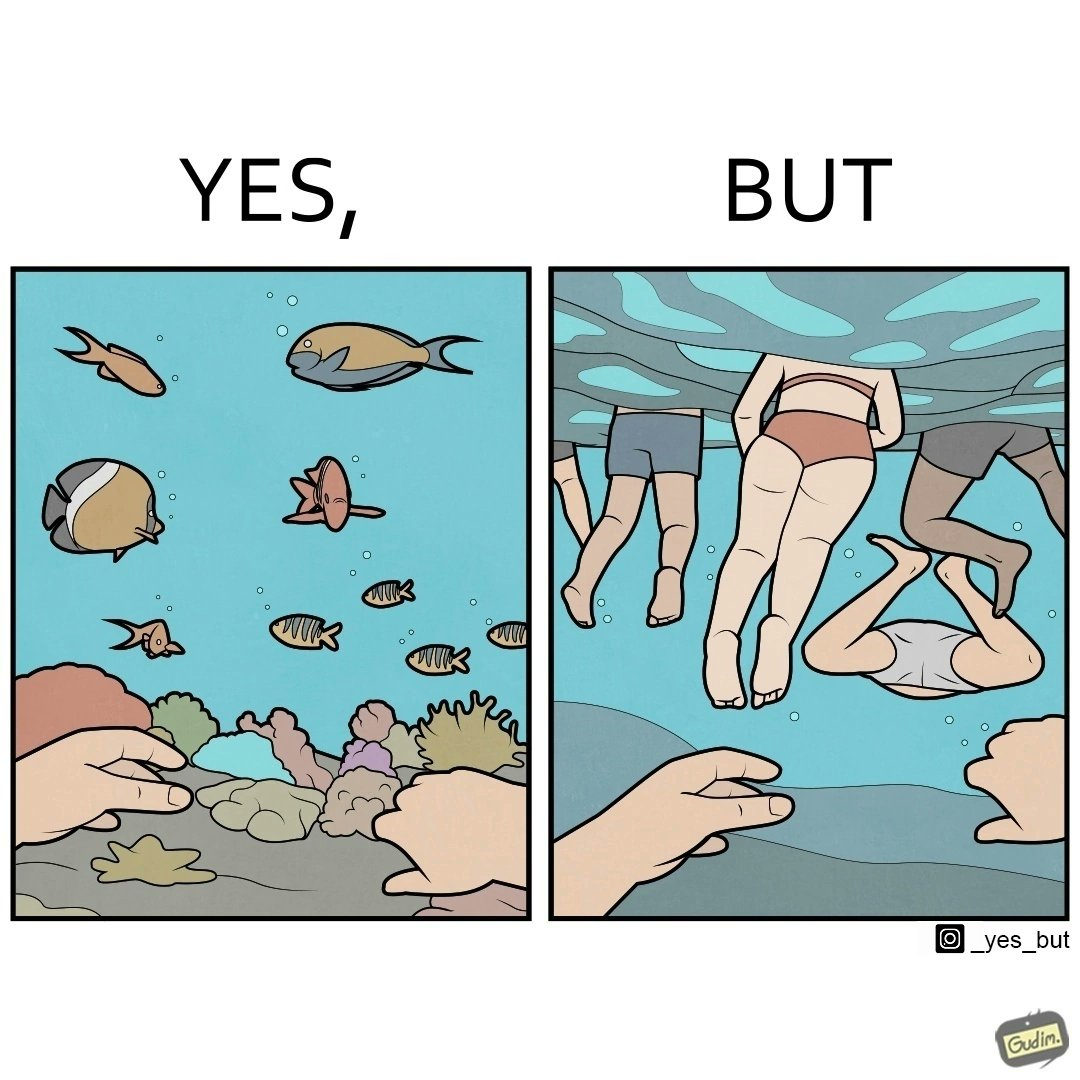What is the satirical meaning behind this image? The image is ironic, because some people like to enjoy watching the biodiversity under water but they are not able to explore this due to excess crowd in such places where people like to play, swim etc. in water 